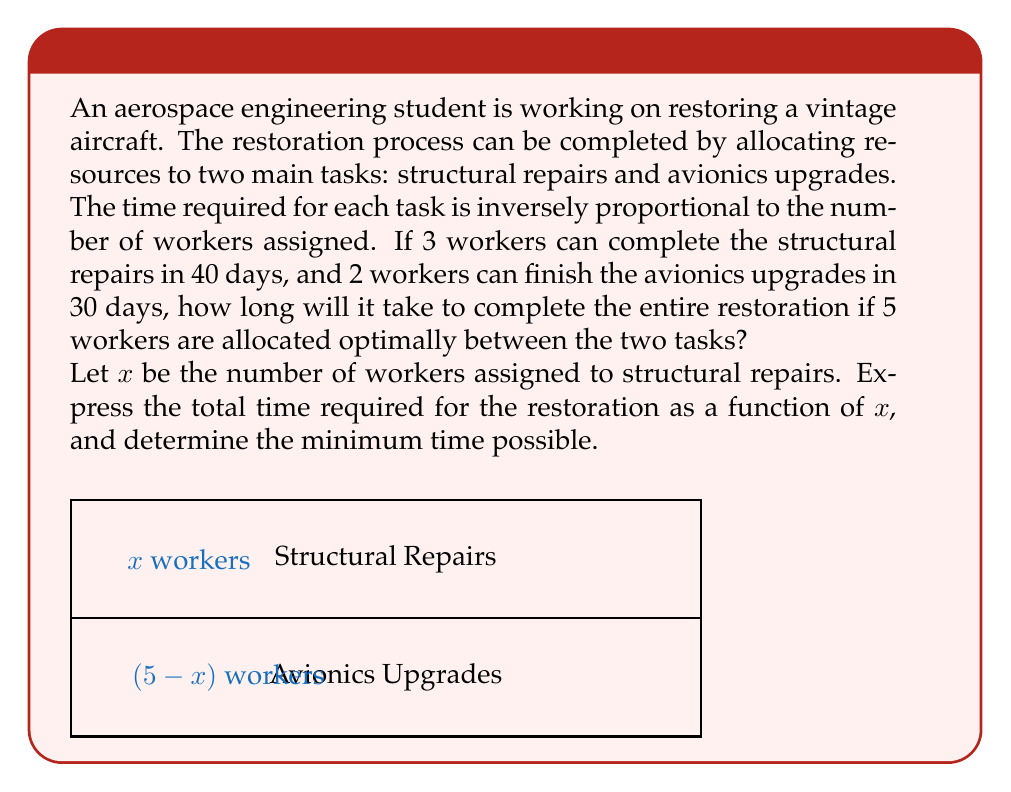Can you answer this question? Let's approach this step-by-step:

1) First, let's express the time for each task as a function of $x$:

   Structural repairs: $T_1 = \frac{3 \cdot 40}{x} = \frac{120}{x}$ days
   Avionics upgrades: $T_2 = \frac{2 \cdot 30}{5-x} = \frac{60}{5-x}$ days

2) The total time $T$ will be the maximum of these two times:

   $T = \max(\frac{120}{x}, \frac{60}{5-x})$

3) To minimize $T$, we need to make these times equal:

   $\frac{120}{x} = \frac{60}{5-x}$

4) Cross-multiply:

   $120(5-x) = 60x$
   $600 - 120x = 60x$
   $600 = 180x$
   $x = \frac{10}{3} \approx 3.33$

5) This means the optimal allocation is about 3.33 workers for structural repairs and 1.67 for avionics upgrades.

6) To find the minimum time, substitute this value of $x$ into either time equation:

   $T_{min} = \frac{120}{\frac{10}{3}} = 36$ days

Therefore, the minimum time for the entire restoration is 36 days.
Answer: 36 days 